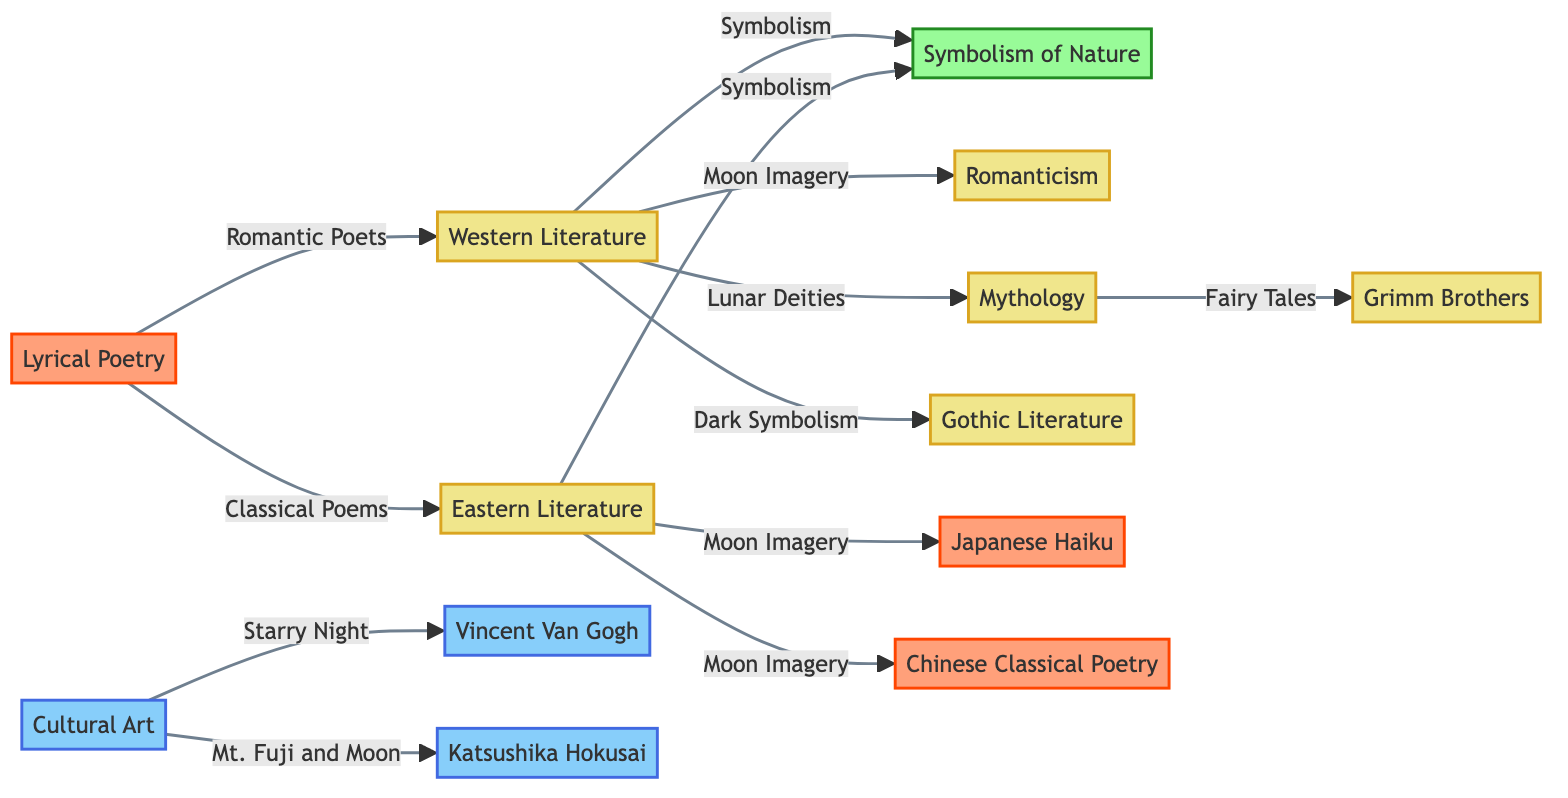What are the two main categories represented in the diagram? The diagram has two main categories represented by Western Literature and Eastern Literature, which are connected to various symbols and art forms regarding the moon.
Answer: Western Literature, Eastern Literature How many types of poetry are connected to Eastern Literature? In the diagram, Eastern Literature is connected to two types of poetry: Japanese Haiku and Chinese Classical Poetry.
Answer: 2 Which artwork is associated with Cultural Art? Cultural Art is specifically connected to two artworks: Starry Night and Mt. Fuji and Moon, as indicated in the diagram.
Answer: Starry Night, Mt. Fuji and Moon What type of literature is linked to the moon imagery in Western Literature? The moon imagery in Western Literature connects to Romanticism and Gothic Literature, indicating two distinct literary styles related to moon symbolism.
Answer: Romanticism, Gothic Literature Which two cultural elements do Western Literature and Eastern Literature share in relation to nature? Both Western Literature and Eastern Literature are linked through the concept of Nature Symbolism, highlighting a common theme in their literary expressions connected to the moon.
Answer: Nature Symbolism What literary connection does the Moon have with Mythology? In the diagram, Mythology is connected to Fairy Tales from the Grimm Brothers, implying that the moon plays a role in narrative traditions involving lunar deities in Western literature.
Answer: Fairy Tales Which artistic movement is represented by Van Gogh’s work related to the moon? The diagram indicates that the artwork Starry Night by Van Gogh is categorized under Cultural Art, referencing an artistic movement that explores celestial themes.
Answer: Starry Night How are Lyrical Poetry and Western Literature interconnected? Lyrical Poetry connects to Romantic Poets, suggesting that poets from this tradition within Western Literature draw inspiration from themes associated with the moon.
Answer: Romantic Poets What role does Symbolism of Nature play in the two primary literary categories? Symbolism of Nature serves as a central element that connects both Western and Eastern Literature, indicating the mutual appreciation of nature and the moon’s influence in their writings.
Answer: Symbolism of Nature 